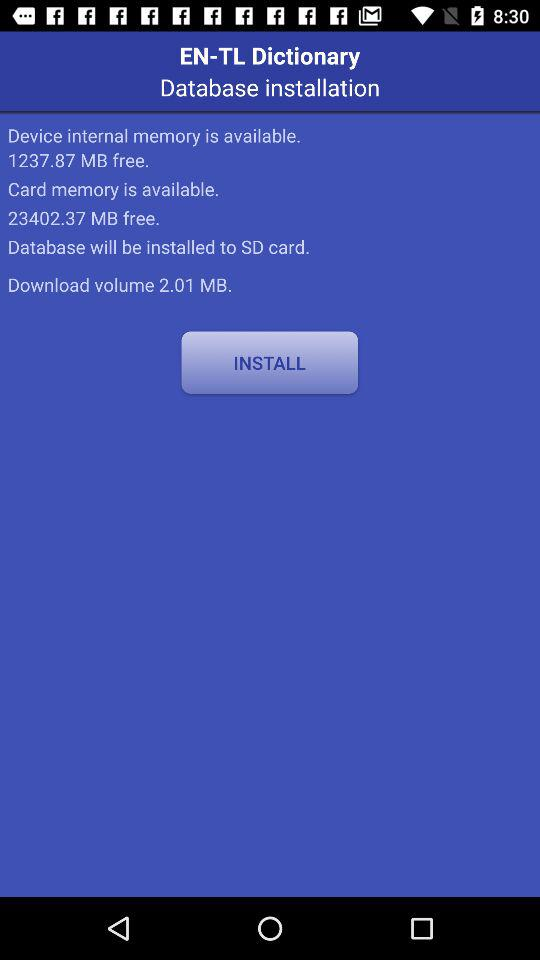Where will the database be installed? The database will be installed to the SD card. 